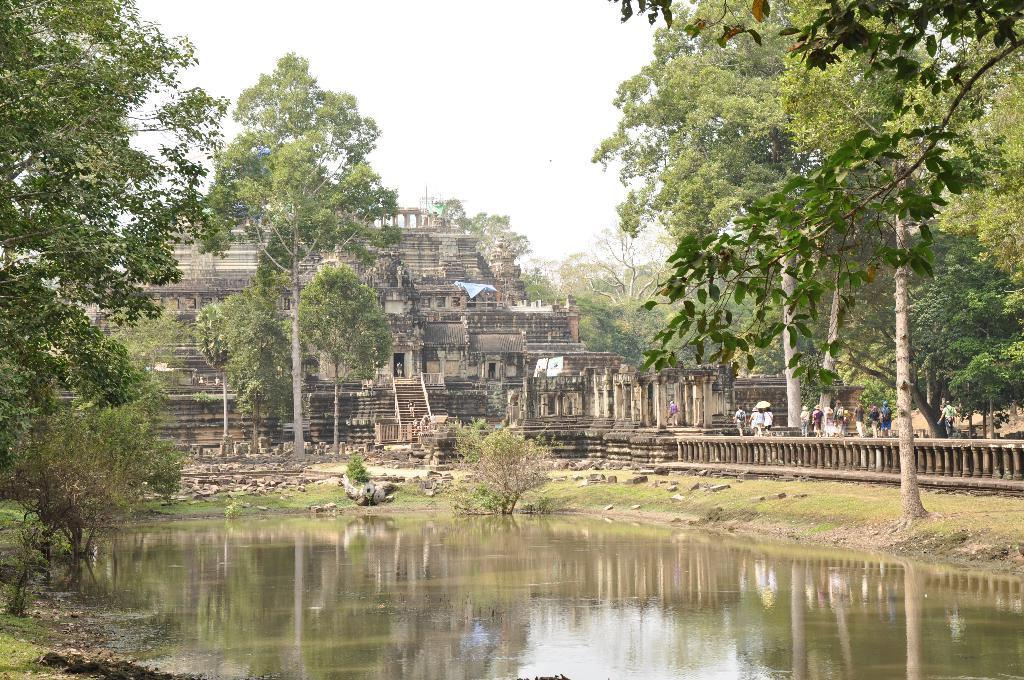What is located in the front of the image? There is water in the front of the image. What type of natural elements can be seen in the image? There are trees visible in the image. What type of man-made structure is present in the image? There is a building in the image. Who or what can be seen in the image? There are people in the image. What is visible in the background of the image? The sky is visible in the background of the image. What type of committee is meeting in the image? There is no committee meeting in the image; it features water, trees, a building, people, and the sky. Can you see any fangs in the image? There are no fangs present in the image. 